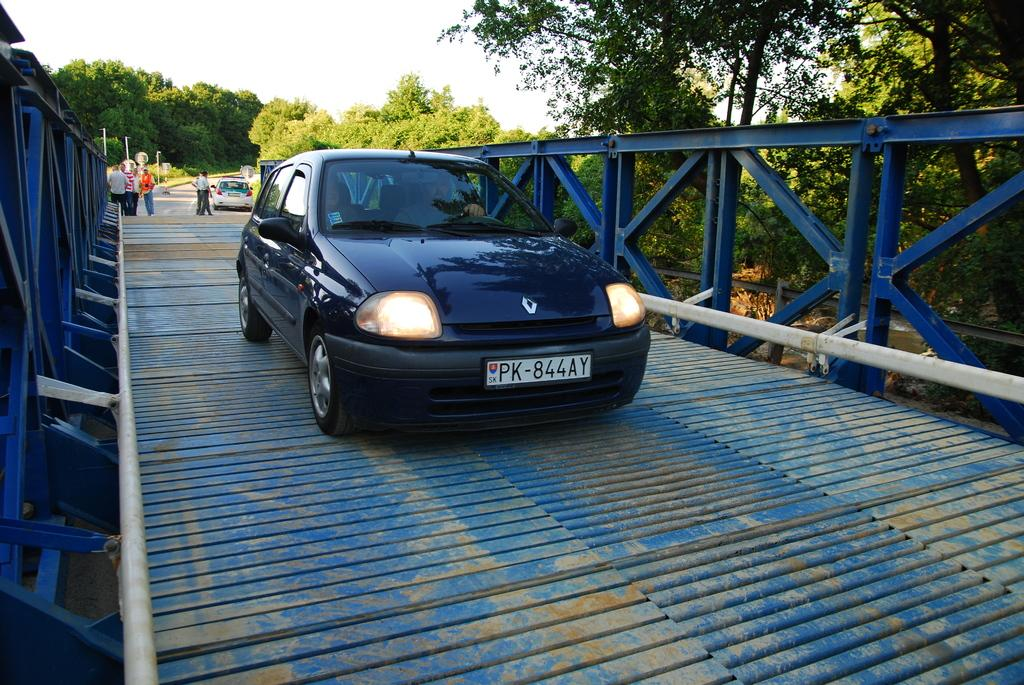What is the main subject in the foreground of the picture? There is a bridge in the foreground of the picture. What is on the bridge? A car is present on the bridge. What can be seen in the background of the picture? There are trees, people, poles, and cars in the background of the picture. How is the weather in the image? The sky is sunny in the image. How does the tooth increase its size in the image? There is no tooth present in the image, so it cannot increase its size. 